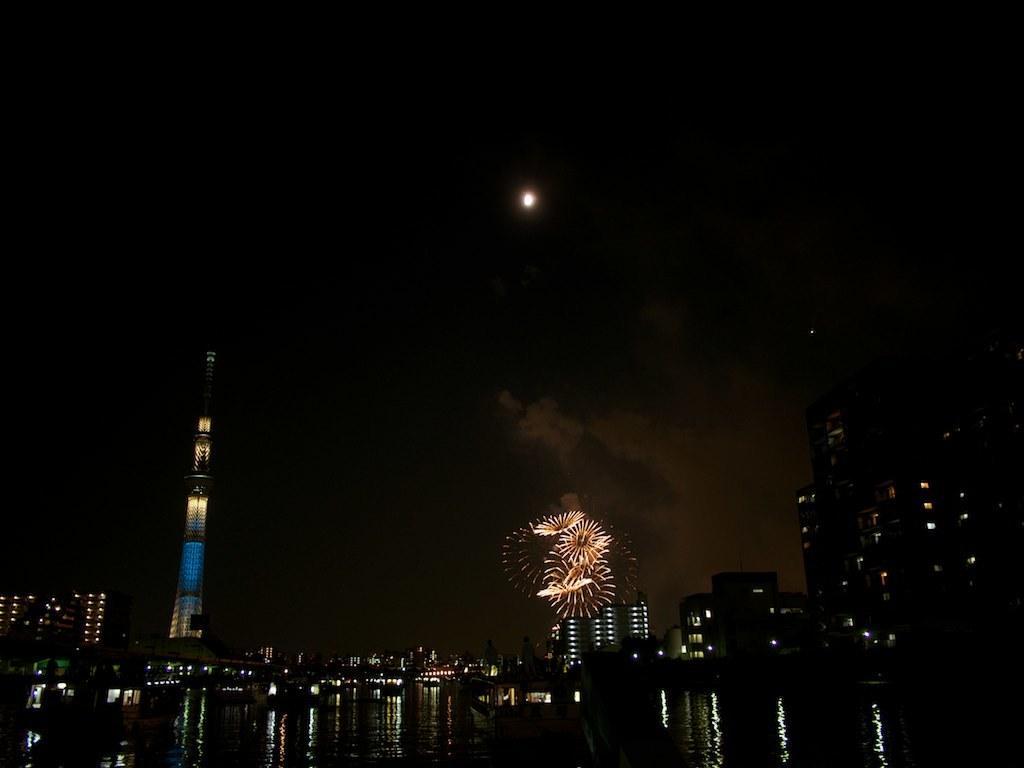Describe this image in one or two sentences. This picture is clicked outside the city. At the bottom of the picture, we see water. There are many buildings and towers. At the top of the picture, we see a moon in the sky. In the background, it is black in color. This picture is clicked in the dark. 